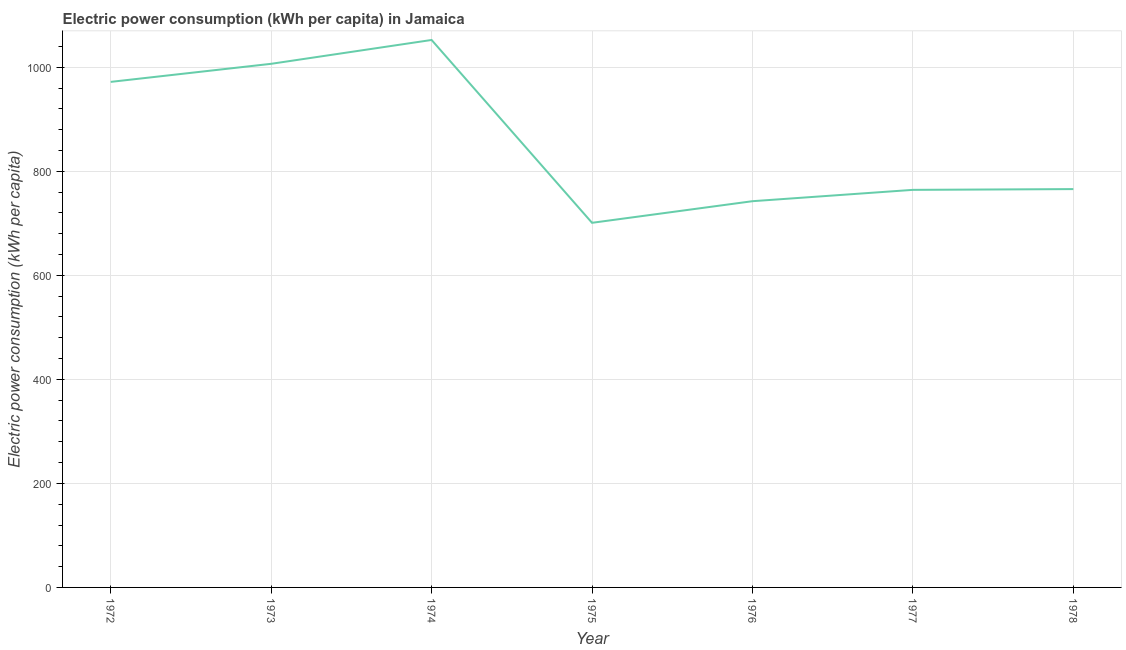What is the electric power consumption in 1973?
Give a very brief answer. 1006.61. Across all years, what is the maximum electric power consumption?
Make the answer very short. 1052.44. Across all years, what is the minimum electric power consumption?
Your response must be concise. 700.94. In which year was the electric power consumption maximum?
Ensure brevity in your answer.  1974. In which year was the electric power consumption minimum?
Your answer should be compact. 1975. What is the sum of the electric power consumption?
Make the answer very short. 6004.41. What is the difference between the electric power consumption in 1977 and 1978?
Your response must be concise. -1.45. What is the average electric power consumption per year?
Ensure brevity in your answer.  857.77. What is the median electric power consumption?
Keep it short and to the point. 765.75. What is the ratio of the electric power consumption in 1974 to that in 1978?
Provide a succinct answer. 1.37. Is the difference between the electric power consumption in 1972 and 1978 greater than the difference between any two years?
Provide a short and direct response. No. What is the difference between the highest and the second highest electric power consumption?
Offer a very short reply. 45.84. Is the sum of the electric power consumption in 1972 and 1977 greater than the maximum electric power consumption across all years?
Your answer should be compact. Yes. What is the difference between the highest and the lowest electric power consumption?
Your answer should be very brief. 351.5. How many lines are there?
Offer a terse response. 1. What is the difference between two consecutive major ticks on the Y-axis?
Make the answer very short. 200. Are the values on the major ticks of Y-axis written in scientific E-notation?
Your response must be concise. No. Does the graph contain any zero values?
Keep it short and to the point. No. What is the title of the graph?
Ensure brevity in your answer.  Electric power consumption (kWh per capita) in Jamaica. What is the label or title of the X-axis?
Provide a short and direct response. Year. What is the label or title of the Y-axis?
Give a very brief answer. Electric power consumption (kWh per capita). What is the Electric power consumption (kWh per capita) of 1972?
Keep it short and to the point. 971.87. What is the Electric power consumption (kWh per capita) of 1973?
Give a very brief answer. 1006.61. What is the Electric power consumption (kWh per capita) in 1974?
Provide a short and direct response. 1052.44. What is the Electric power consumption (kWh per capita) of 1975?
Provide a succinct answer. 700.94. What is the Electric power consumption (kWh per capita) of 1976?
Give a very brief answer. 742.5. What is the Electric power consumption (kWh per capita) in 1977?
Ensure brevity in your answer.  764.3. What is the Electric power consumption (kWh per capita) of 1978?
Offer a terse response. 765.75. What is the difference between the Electric power consumption (kWh per capita) in 1972 and 1973?
Give a very brief answer. -34.74. What is the difference between the Electric power consumption (kWh per capita) in 1972 and 1974?
Offer a very short reply. -80.58. What is the difference between the Electric power consumption (kWh per capita) in 1972 and 1975?
Keep it short and to the point. 270.92. What is the difference between the Electric power consumption (kWh per capita) in 1972 and 1976?
Keep it short and to the point. 229.37. What is the difference between the Electric power consumption (kWh per capita) in 1972 and 1977?
Give a very brief answer. 207.57. What is the difference between the Electric power consumption (kWh per capita) in 1972 and 1978?
Provide a short and direct response. 206.11. What is the difference between the Electric power consumption (kWh per capita) in 1973 and 1974?
Ensure brevity in your answer.  -45.84. What is the difference between the Electric power consumption (kWh per capita) in 1973 and 1975?
Offer a very short reply. 305.66. What is the difference between the Electric power consumption (kWh per capita) in 1973 and 1976?
Offer a terse response. 264.11. What is the difference between the Electric power consumption (kWh per capita) in 1973 and 1977?
Offer a terse response. 242.3. What is the difference between the Electric power consumption (kWh per capita) in 1973 and 1978?
Offer a very short reply. 240.85. What is the difference between the Electric power consumption (kWh per capita) in 1974 and 1975?
Your response must be concise. 351.5. What is the difference between the Electric power consumption (kWh per capita) in 1974 and 1976?
Provide a succinct answer. 309.95. What is the difference between the Electric power consumption (kWh per capita) in 1974 and 1977?
Your answer should be very brief. 288.14. What is the difference between the Electric power consumption (kWh per capita) in 1974 and 1978?
Your answer should be very brief. 286.69. What is the difference between the Electric power consumption (kWh per capita) in 1975 and 1976?
Make the answer very short. -41.55. What is the difference between the Electric power consumption (kWh per capita) in 1975 and 1977?
Make the answer very short. -63.36. What is the difference between the Electric power consumption (kWh per capita) in 1975 and 1978?
Ensure brevity in your answer.  -64.81. What is the difference between the Electric power consumption (kWh per capita) in 1976 and 1977?
Your response must be concise. -21.8. What is the difference between the Electric power consumption (kWh per capita) in 1976 and 1978?
Offer a terse response. -23.25. What is the difference between the Electric power consumption (kWh per capita) in 1977 and 1978?
Provide a succinct answer. -1.45. What is the ratio of the Electric power consumption (kWh per capita) in 1972 to that in 1974?
Ensure brevity in your answer.  0.92. What is the ratio of the Electric power consumption (kWh per capita) in 1972 to that in 1975?
Offer a terse response. 1.39. What is the ratio of the Electric power consumption (kWh per capita) in 1972 to that in 1976?
Keep it short and to the point. 1.31. What is the ratio of the Electric power consumption (kWh per capita) in 1972 to that in 1977?
Offer a terse response. 1.27. What is the ratio of the Electric power consumption (kWh per capita) in 1972 to that in 1978?
Provide a short and direct response. 1.27. What is the ratio of the Electric power consumption (kWh per capita) in 1973 to that in 1974?
Offer a terse response. 0.96. What is the ratio of the Electric power consumption (kWh per capita) in 1973 to that in 1975?
Give a very brief answer. 1.44. What is the ratio of the Electric power consumption (kWh per capita) in 1973 to that in 1976?
Your answer should be very brief. 1.36. What is the ratio of the Electric power consumption (kWh per capita) in 1973 to that in 1977?
Provide a succinct answer. 1.32. What is the ratio of the Electric power consumption (kWh per capita) in 1973 to that in 1978?
Offer a very short reply. 1.31. What is the ratio of the Electric power consumption (kWh per capita) in 1974 to that in 1975?
Ensure brevity in your answer.  1.5. What is the ratio of the Electric power consumption (kWh per capita) in 1974 to that in 1976?
Your answer should be very brief. 1.42. What is the ratio of the Electric power consumption (kWh per capita) in 1974 to that in 1977?
Offer a terse response. 1.38. What is the ratio of the Electric power consumption (kWh per capita) in 1974 to that in 1978?
Offer a terse response. 1.37. What is the ratio of the Electric power consumption (kWh per capita) in 1975 to that in 1976?
Keep it short and to the point. 0.94. What is the ratio of the Electric power consumption (kWh per capita) in 1975 to that in 1977?
Ensure brevity in your answer.  0.92. What is the ratio of the Electric power consumption (kWh per capita) in 1975 to that in 1978?
Make the answer very short. 0.92. What is the ratio of the Electric power consumption (kWh per capita) in 1976 to that in 1977?
Provide a short and direct response. 0.97. 